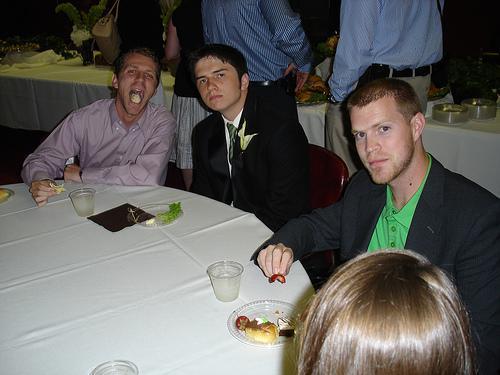How many people are in the photo?
Give a very brief answer. 8. How many men are seated?
Give a very brief answer. 3. 